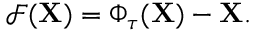<formula> <loc_0><loc_0><loc_500><loc_500>\mathcal { F } ( X ) = \Phi _ { \tau } ( X ) - X .</formula> 